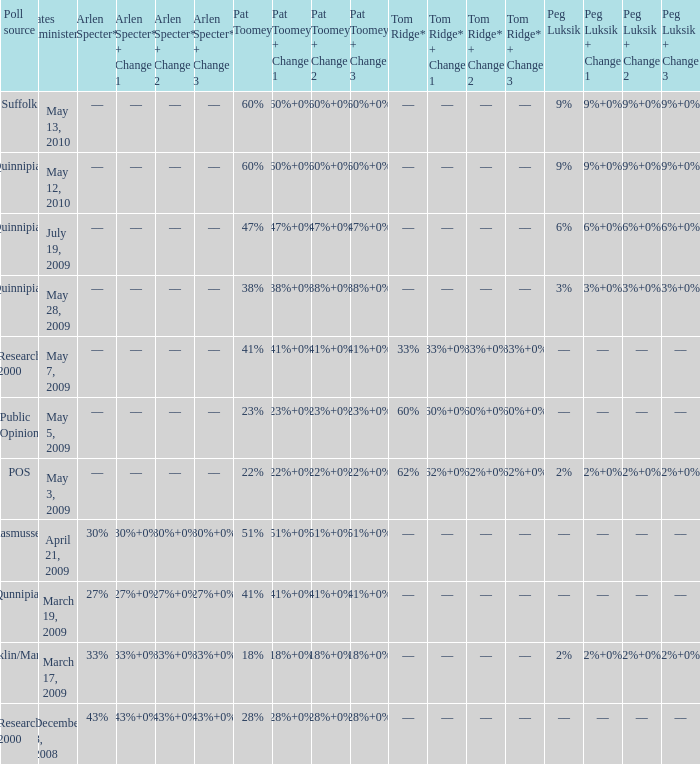Which Poll source has Pat Toomey of 23%? Public Opinion. 